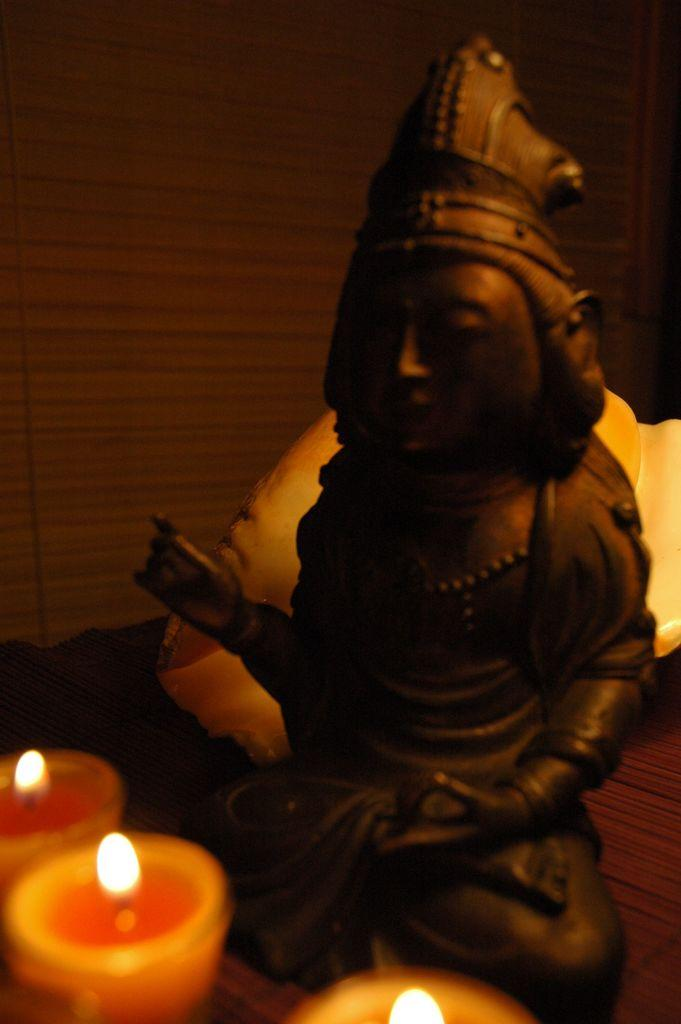What is the main subject of the image? There is a god statue in the image. What is placed in front of the statue? There are three candles in front of the statue. Can you describe the background of the image? The background of the image has brown and black colors. How many rabbits can be seen playing in the snow in the image? There are no rabbits or snow present in the image. What type of washing machine is visible in the image? There is no washing machine present in the image. 